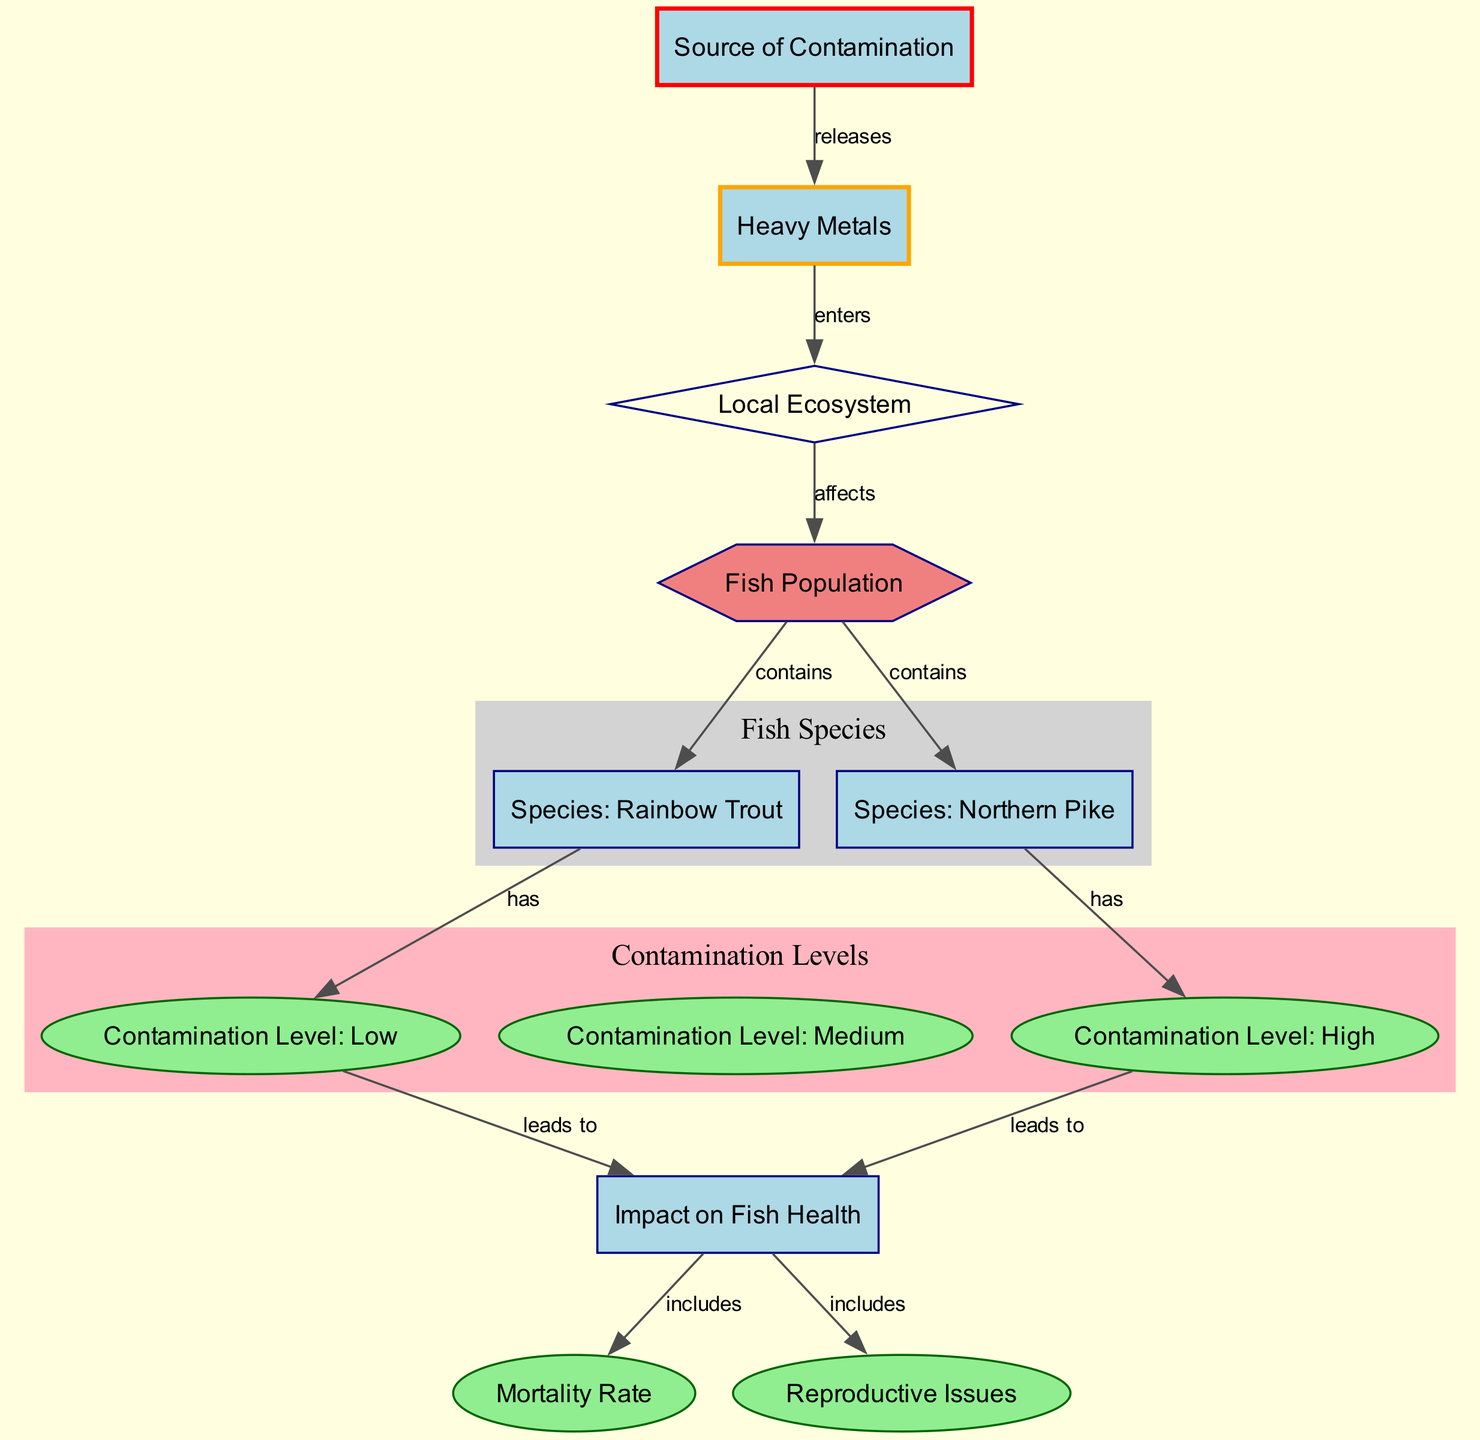What does the source of contamination release? The diagram shows that the source of contamination releases heavy metals. This is indicated by the directed edge from "source_of_contamination" to "heavy_metals.”
Answer: heavy metals How many fish species are contained in the fish population? The diagram indicates that the fish population contains two species, Rainbow Trout and Northern Pike. This is shown by the edges leading from "fish_population" to both "species_1" and "species_2."
Answer: 2 What contamination level does the Rainbow Trout have? In the diagram, Rainbow Trout (Species 1) has a contamination level classified as low. This can be seen through the edge connecting "species_1" to "contamination_level_1."
Answer: low What are the two impacts on fish health? The diagram reveals two impacts that affect fish health, which are included in the node "impact_on_fish_health." The two impacts are "mortality_rate" and "reproductive_issues." This is indicated by the edges leading from "impact_on_fish_health" to both attributes.
Answer: mortality rate, reproductive issues Which species has a high contamination level? According to the diagram, Northern Pike (Species 2) is indicated to have a contamination level that is categorized as high. This is reflected in the edge from "species_2" to "contamination_level_3."
Answer: high What type of interaction exists between heavy metals and the local ecosystem? The diagram describes the interaction in terms of direction. Heavy metals enters the local ecosystem, which is represented by the directed edge from "heavy_metals" to "local_ecosystem."
Answer: enters How many attributes represent contamination levels? The diagram contains three different contamination levels represented as attributes: low, medium, and high. This is confirmed by the nodes "contamination_level_1," "contamination_level_2," and "contamination_level_3."
Answer: 3 What is the relationship between medium contamination level and impact on fish health? The diagram indicates that a medium contamination level does not directly appear. Therefore, it does not show a specific relationship. The focus is on low and high levels affecting fish health. There are no edges from medium contamination to the impacts on fish health.
Answer: none 